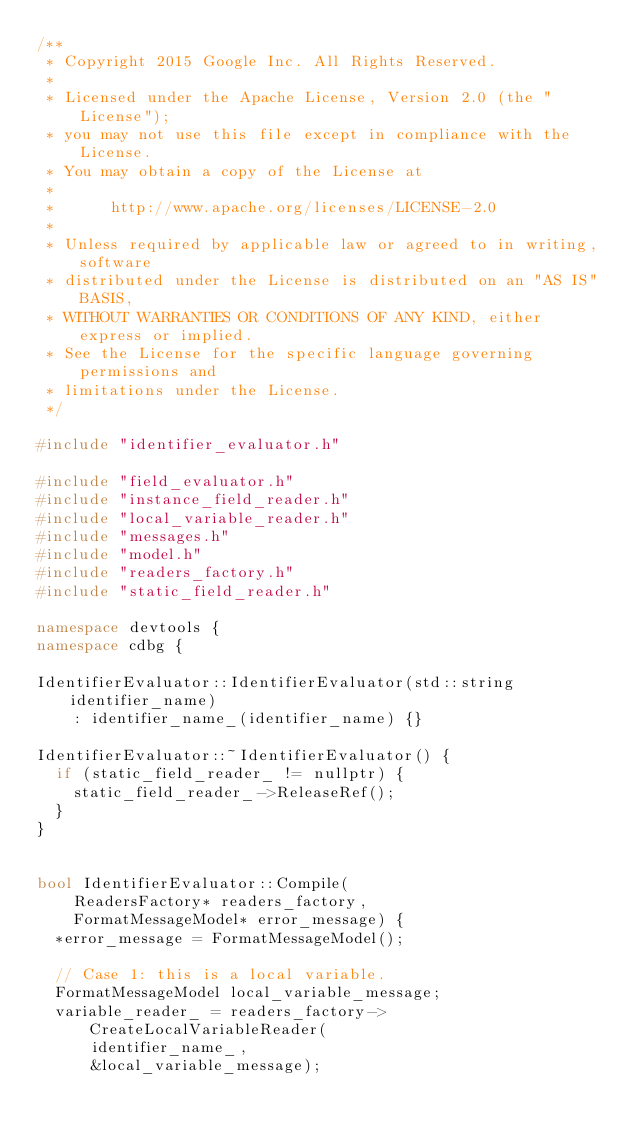<code> <loc_0><loc_0><loc_500><loc_500><_C++_>/**
 * Copyright 2015 Google Inc. All Rights Reserved.
 *
 * Licensed under the Apache License, Version 2.0 (the "License");
 * you may not use this file except in compliance with the License.
 * You may obtain a copy of the License at
 *
 *      http://www.apache.org/licenses/LICENSE-2.0
 *
 * Unless required by applicable law or agreed to in writing, software
 * distributed under the License is distributed on an "AS IS" BASIS,
 * WITHOUT WARRANTIES OR CONDITIONS OF ANY KIND, either express or implied.
 * See the License for the specific language governing permissions and
 * limitations under the License.
 */

#include "identifier_evaluator.h"

#include "field_evaluator.h"
#include "instance_field_reader.h"
#include "local_variable_reader.h"
#include "messages.h"
#include "model.h"
#include "readers_factory.h"
#include "static_field_reader.h"

namespace devtools {
namespace cdbg {

IdentifierEvaluator::IdentifierEvaluator(std::string identifier_name)
    : identifier_name_(identifier_name) {}

IdentifierEvaluator::~IdentifierEvaluator() {
  if (static_field_reader_ != nullptr) {
    static_field_reader_->ReleaseRef();
  }
}


bool IdentifierEvaluator::Compile(
    ReadersFactory* readers_factory,
    FormatMessageModel* error_message) {
  *error_message = FormatMessageModel();

  // Case 1: this is a local variable.
  FormatMessageModel local_variable_message;
  variable_reader_ = readers_factory->CreateLocalVariableReader(
      identifier_name_,
      &local_variable_message);</code> 